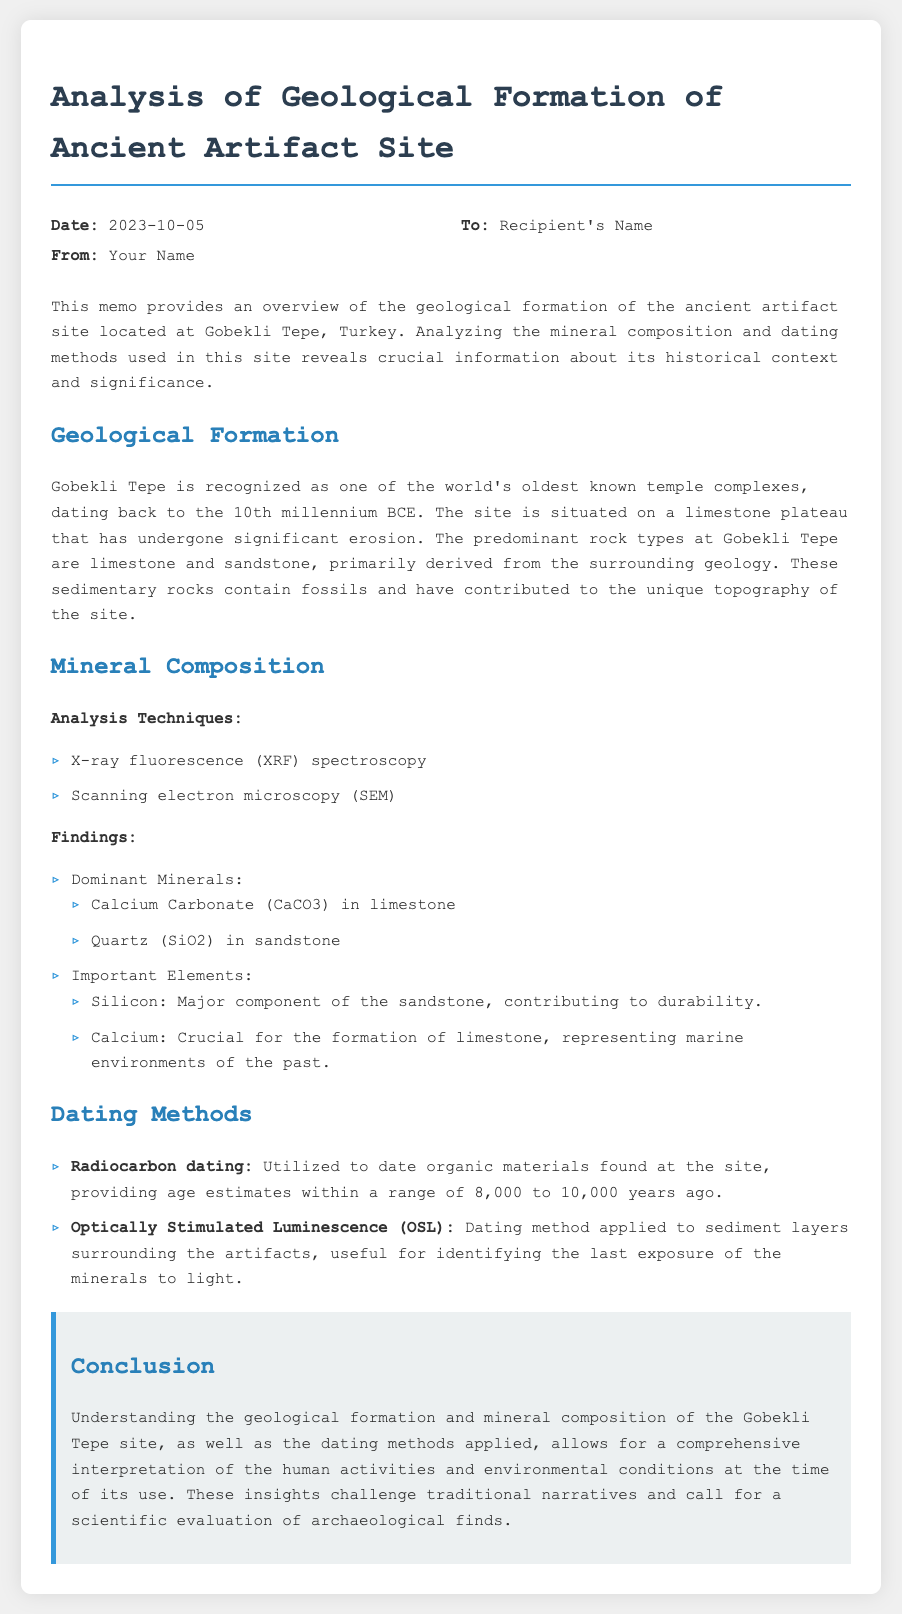What is the date of the memo? The date is mentioned in the header section of the memo.
Answer: 2023-10-05 What is the location of the ancient artifact site? The location is specified in the introduction of the memo.
Answer: Gobekli Tepe, Turkey What minerals are dominant in the geological formation? The findings section lists the dominant minerals found in the formation.
Answer: Calcium Carbonate and Quartz What dating method is used for organic materials? The specific dating method for organic materials is stated in the Dating Methods section.
Answer: Radiocarbon dating What is the age range provided by radiocarbon dating? The age range is provided in the details of the dating methods utilized.
Answer: 8,000 to 10,000 years ago Which rock types are predominant at the site? The rock types are identified in the Geological Formation section of the memo.
Answer: Limestone and Sandstone What analysis technique is mentioned for mineral composition analysis? The analysis techniques are listed under the Mineral Composition section.
Answer: X-ray fluorescence (XRF) spectroscopy What does the conclusion emphasize? The conclusion summarizes the main insights regarding the geological analysis and its implications.
Answer: Scientific evaluation of archaeological finds 